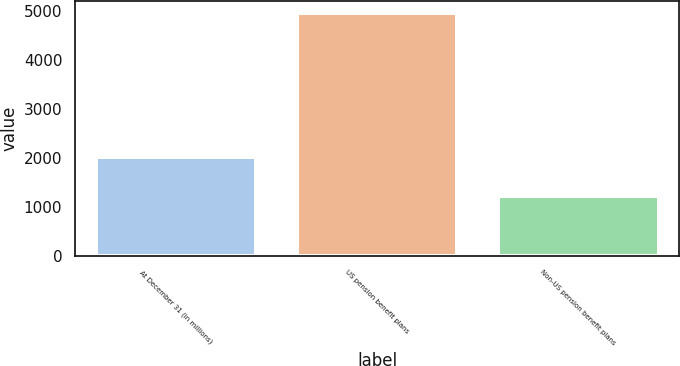<chart> <loc_0><loc_0><loc_500><loc_500><bar_chart><fcel>At December 31 (in millions)<fcel>US pension benefit plans<fcel>Non-US pension benefit plans<nl><fcel>2016<fcel>4948<fcel>1215<nl></chart> 